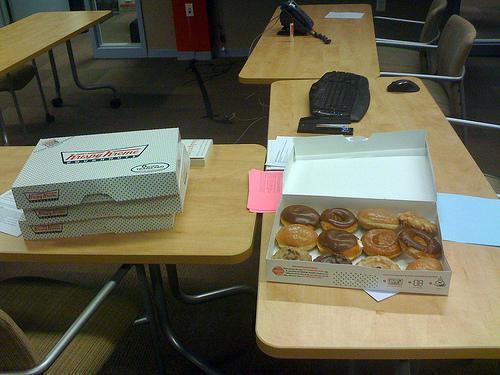How many boxes are on the tables?
Give a very brief answer. 4. How many boxes are shown?
Give a very brief answer. 4. How many boxes are in the stack?
Give a very brief answer. 3. How many boxes of doughnuts are open?
Give a very brief answer. 1. 